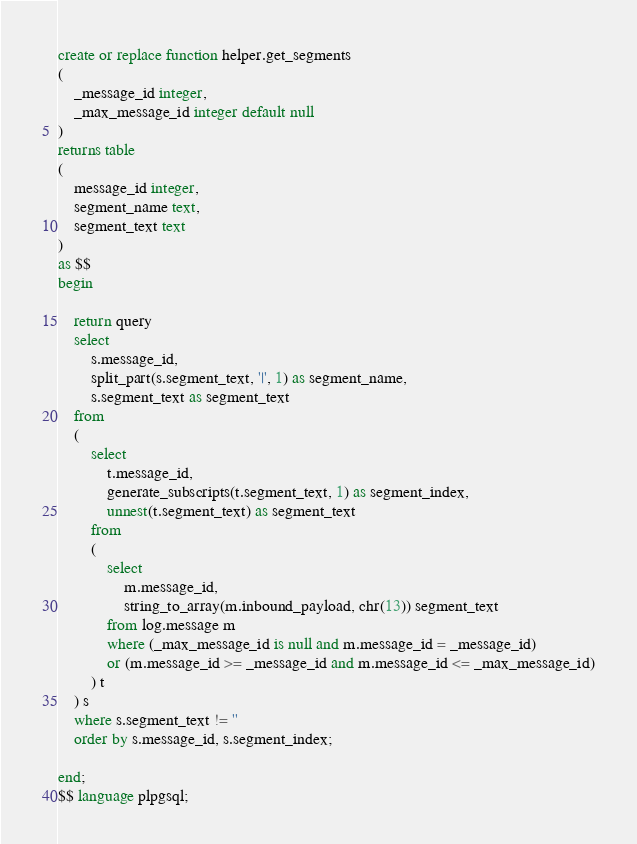<code> <loc_0><loc_0><loc_500><loc_500><_SQL_>
create or replace function helper.get_segments
(
	_message_id integer,
	_max_message_id integer default null
)
returns table
(
	message_id integer,
	segment_name text,
	segment_text text
)
as $$
begin

	return query
	select 
		s.message_id,
		split_part(s.segment_text, '|', 1) as segment_name,
		s.segment_text as segment_text
	from
	(
		select 
			t.message_id,
			generate_subscripts(t.segment_text, 1) as segment_index,
			unnest(t.segment_text) as segment_text
		from
		(
			select 
				m.message_id,
				string_to_array(m.inbound_payload, chr(13)) segment_text
			from log.message m
			where (_max_message_id is null and m.message_id = _message_id) 
			or (m.message_id >= _message_id and m.message_id <= _max_message_id)
		) t
	) s
	where s.segment_text != ''
	order by s.message_id, s.segment_index;

end;
$$ language plpgsql;
</code> 